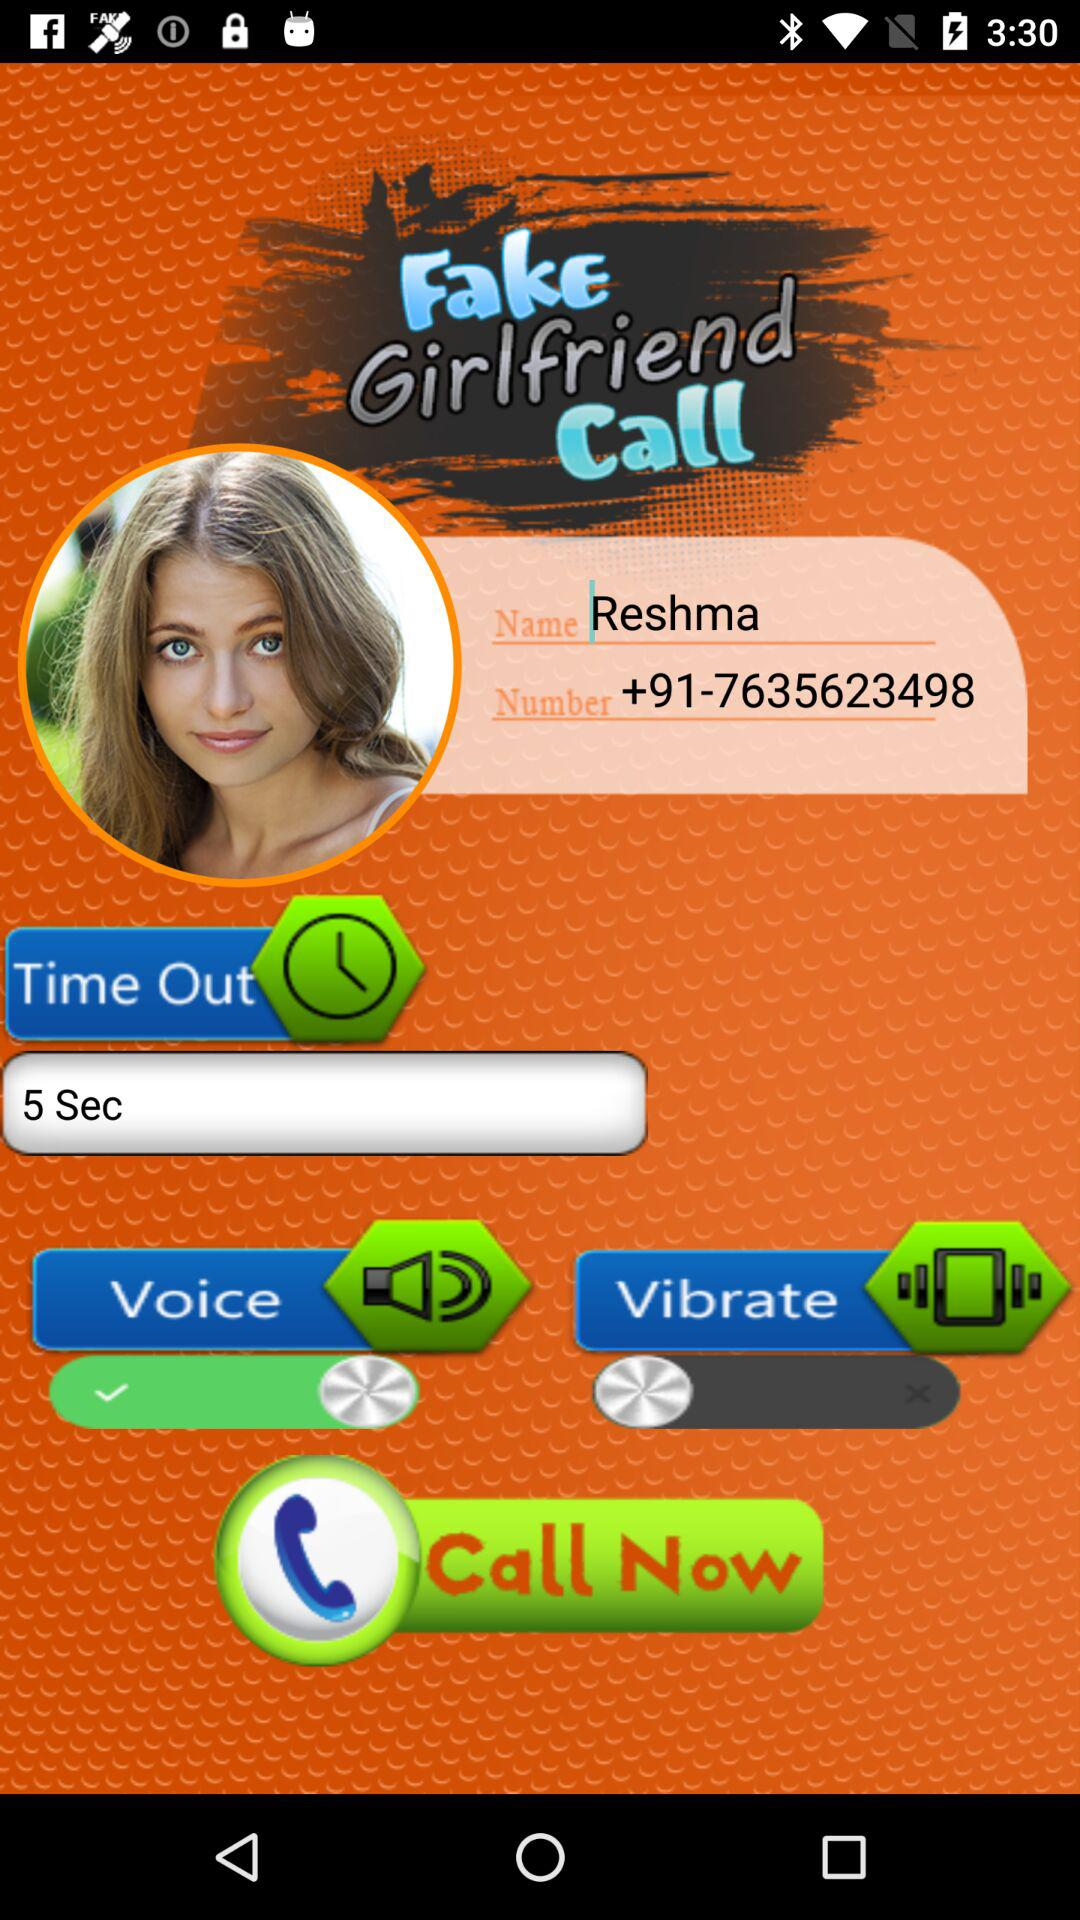What is the time duration for time out? The time duration for time out is 5 seconds. 